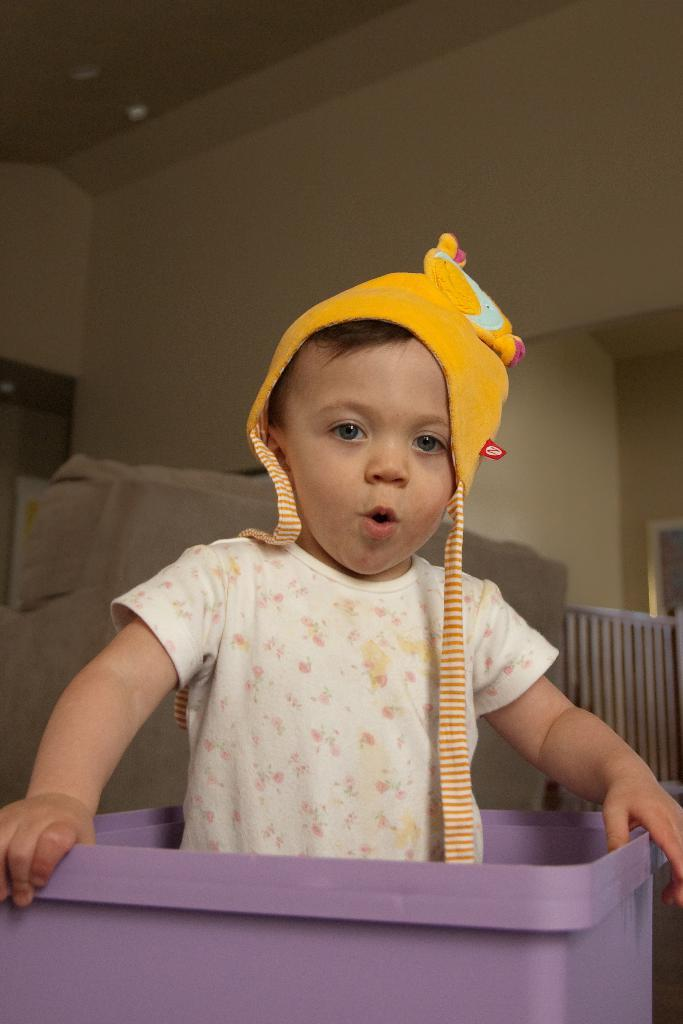Who is the main subject in the image? There is a boy in the image. Where is the boy located? The boy is inside an object. What can be seen in the background of the image? There is a wall in the background of the image. What direction is the boy stepping in the image? There is no indication of the boy stepping or moving in any direction in the image. 